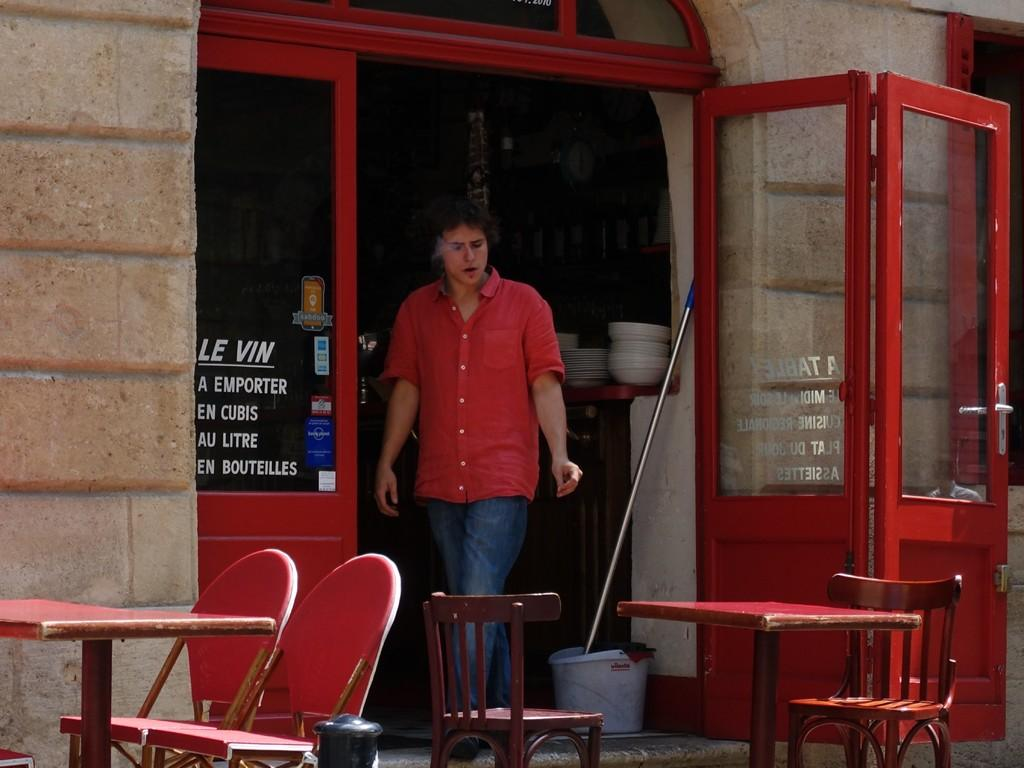Who is present in the image? There is a man in the image. What is the man doing in the image? The man is smoking a cigarette. Where is the man located in the image? The man is behind tables and chairs. What objects can be seen on the tables or chairs? There are plates visible in the image. What type of container is present in the image? There is a bucket in the image. What architectural feature is visible in the image? There are doors in the image. What type of wristwatch is the man wearing in the image? There is no wristwatch visible on the man in the image. What emotion does the man express in the image? The image does not convey any specific emotion or regret. 